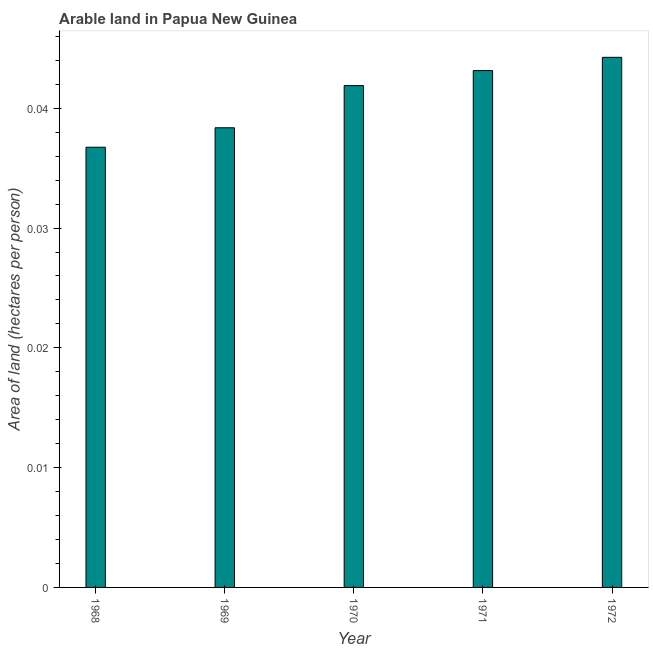What is the title of the graph?
Offer a terse response. Arable land in Papua New Guinea. What is the label or title of the Y-axis?
Offer a terse response. Area of land (hectares per person). What is the area of arable land in 1972?
Your answer should be very brief. 0.04. Across all years, what is the maximum area of arable land?
Give a very brief answer. 0.04. Across all years, what is the minimum area of arable land?
Offer a terse response. 0.04. In which year was the area of arable land minimum?
Offer a terse response. 1968. What is the sum of the area of arable land?
Keep it short and to the point. 0.2. What is the difference between the area of arable land in 1970 and 1971?
Your answer should be very brief. -0. What is the average area of arable land per year?
Your answer should be very brief. 0.04. What is the median area of arable land?
Your answer should be very brief. 0.04. In how many years, is the area of arable land greater than 0.036 hectares per person?
Make the answer very short. 5. What is the ratio of the area of arable land in 1968 to that in 1971?
Offer a very short reply. 0.85. In how many years, is the area of arable land greater than the average area of arable land taken over all years?
Your answer should be very brief. 3. How many years are there in the graph?
Keep it short and to the point. 5. What is the difference between two consecutive major ticks on the Y-axis?
Your answer should be compact. 0.01. What is the Area of land (hectares per person) of 1968?
Your answer should be very brief. 0.04. What is the Area of land (hectares per person) of 1969?
Your answer should be compact. 0.04. What is the Area of land (hectares per person) in 1970?
Your response must be concise. 0.04. What is the Area of land (hectares per person) in 1971?
Your response must be concise. 0.04. What is the Area of land (hectares per person) of 1972?
Provide a succinct answer. 0.04. What is the difference between the Area of land (hectares per person) in 1968 and 1969?
Your answer should be compact. -0. What is the difference between the Area of land (hectares per person) in 1968 and 1970?
Your answer should be very brief. -0.01. What is the difference between the Area of land (hectares per person) in 1968 and 1971?
Ensure brevity in your answer.  -0.01. What is the difference between the Area of land (hectares per person) in 1968 and 1972?
Your answer should be very brief. -0.01. What is the difference between the Area of land (hectares per person) in 1969 and 1970?
Provide a succinct answer. -0. What is the difference between the Area of land (hectares per person) in 1969 and 1971?
Keep it short and to the point. -0. What is the difference between the Area of land (hectares per person) in 1969 and 1972?
Make the answer very short. -0.01. What is the difference between the Area of land (hectares per person) in 1970 and 1971?
Provide a short and direct response. -0. What is the difference between the Area of land (hectares per person) in 1970 and 1972?
Your answer should be very brief. -0. What is the difference between the Area of land (hectares per person) in 1971 and 1972?
Your response must be concise. -0. What is the ratio of the Area of land (hectares per person) in 1968 to that in 1969?
Make the answer very short. 0.96. What is the ratio of the Area of land (hectares per person) in 1968 to that in 1970?
Give a very brief answer. 0.88. What is the ratio of the Area of land (hectares per person) in 1968 to that in 1971?
Offer a very short reply. 0.85. What is the ratio of the Area of land (hectares per person) in 1968 to that in 1972?
Your answer should be very brief. 0.83. What is the ratio of the Area of land (hectares per person) in 1969 to that in 1970?
Keep it short and to the point. 0.92. What is the ratio of the Area of land (hectares per person) in 1969 to that in 1971?
Provide a succinct answer. 0.89. What is the ratio of the Area of land (hectares per person) in 1969 to that in 1972?
Give a very brief answer. 0.87. What is the ratio of the Area of land (hectares per person) in 1970 to that in 1972?
Ensure brevity in your answer.  0.95. What is the ratio of the Area of land (hectares per person) in 1971 to that in 1972?
Make the answer very short. 0.97. 